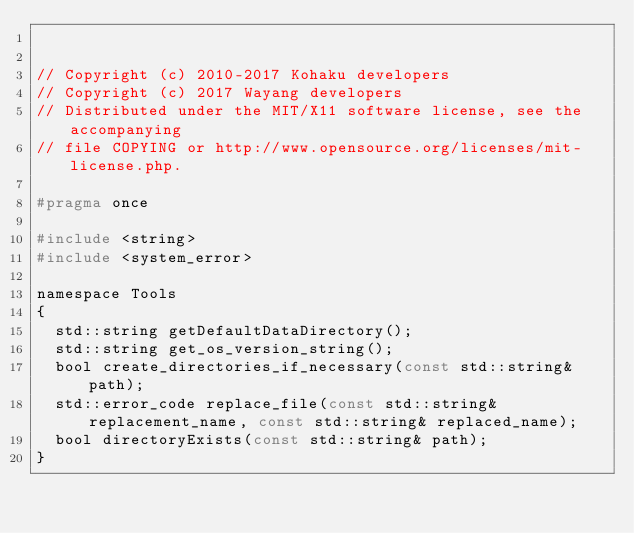Convert code to text. <code><loc_0><loc_0><loc_500><loc_500><_C_> 
 
// Copyright (c) 2010-2017 Kohaku developers
// Copyright (c) 2017 Wayang developers
// Distributed under the MIT/X11 software license, see the accompanying
// file COPYING or http://www.opensource.org/licenses/mit-license.php.

#pragma once 

#include <string>
#include <system_error>

namespace Tools
{
  std::string getDefaultDataDirectory();
  std::string get_os_version_string();
  bool create_directories_if_necessary(const std::string& path);
  std::error_code replace_file(const std::string& replacement_name, const std::string& replaced_name);
  bool directoryExists(const std::string& path);
}
</code> 